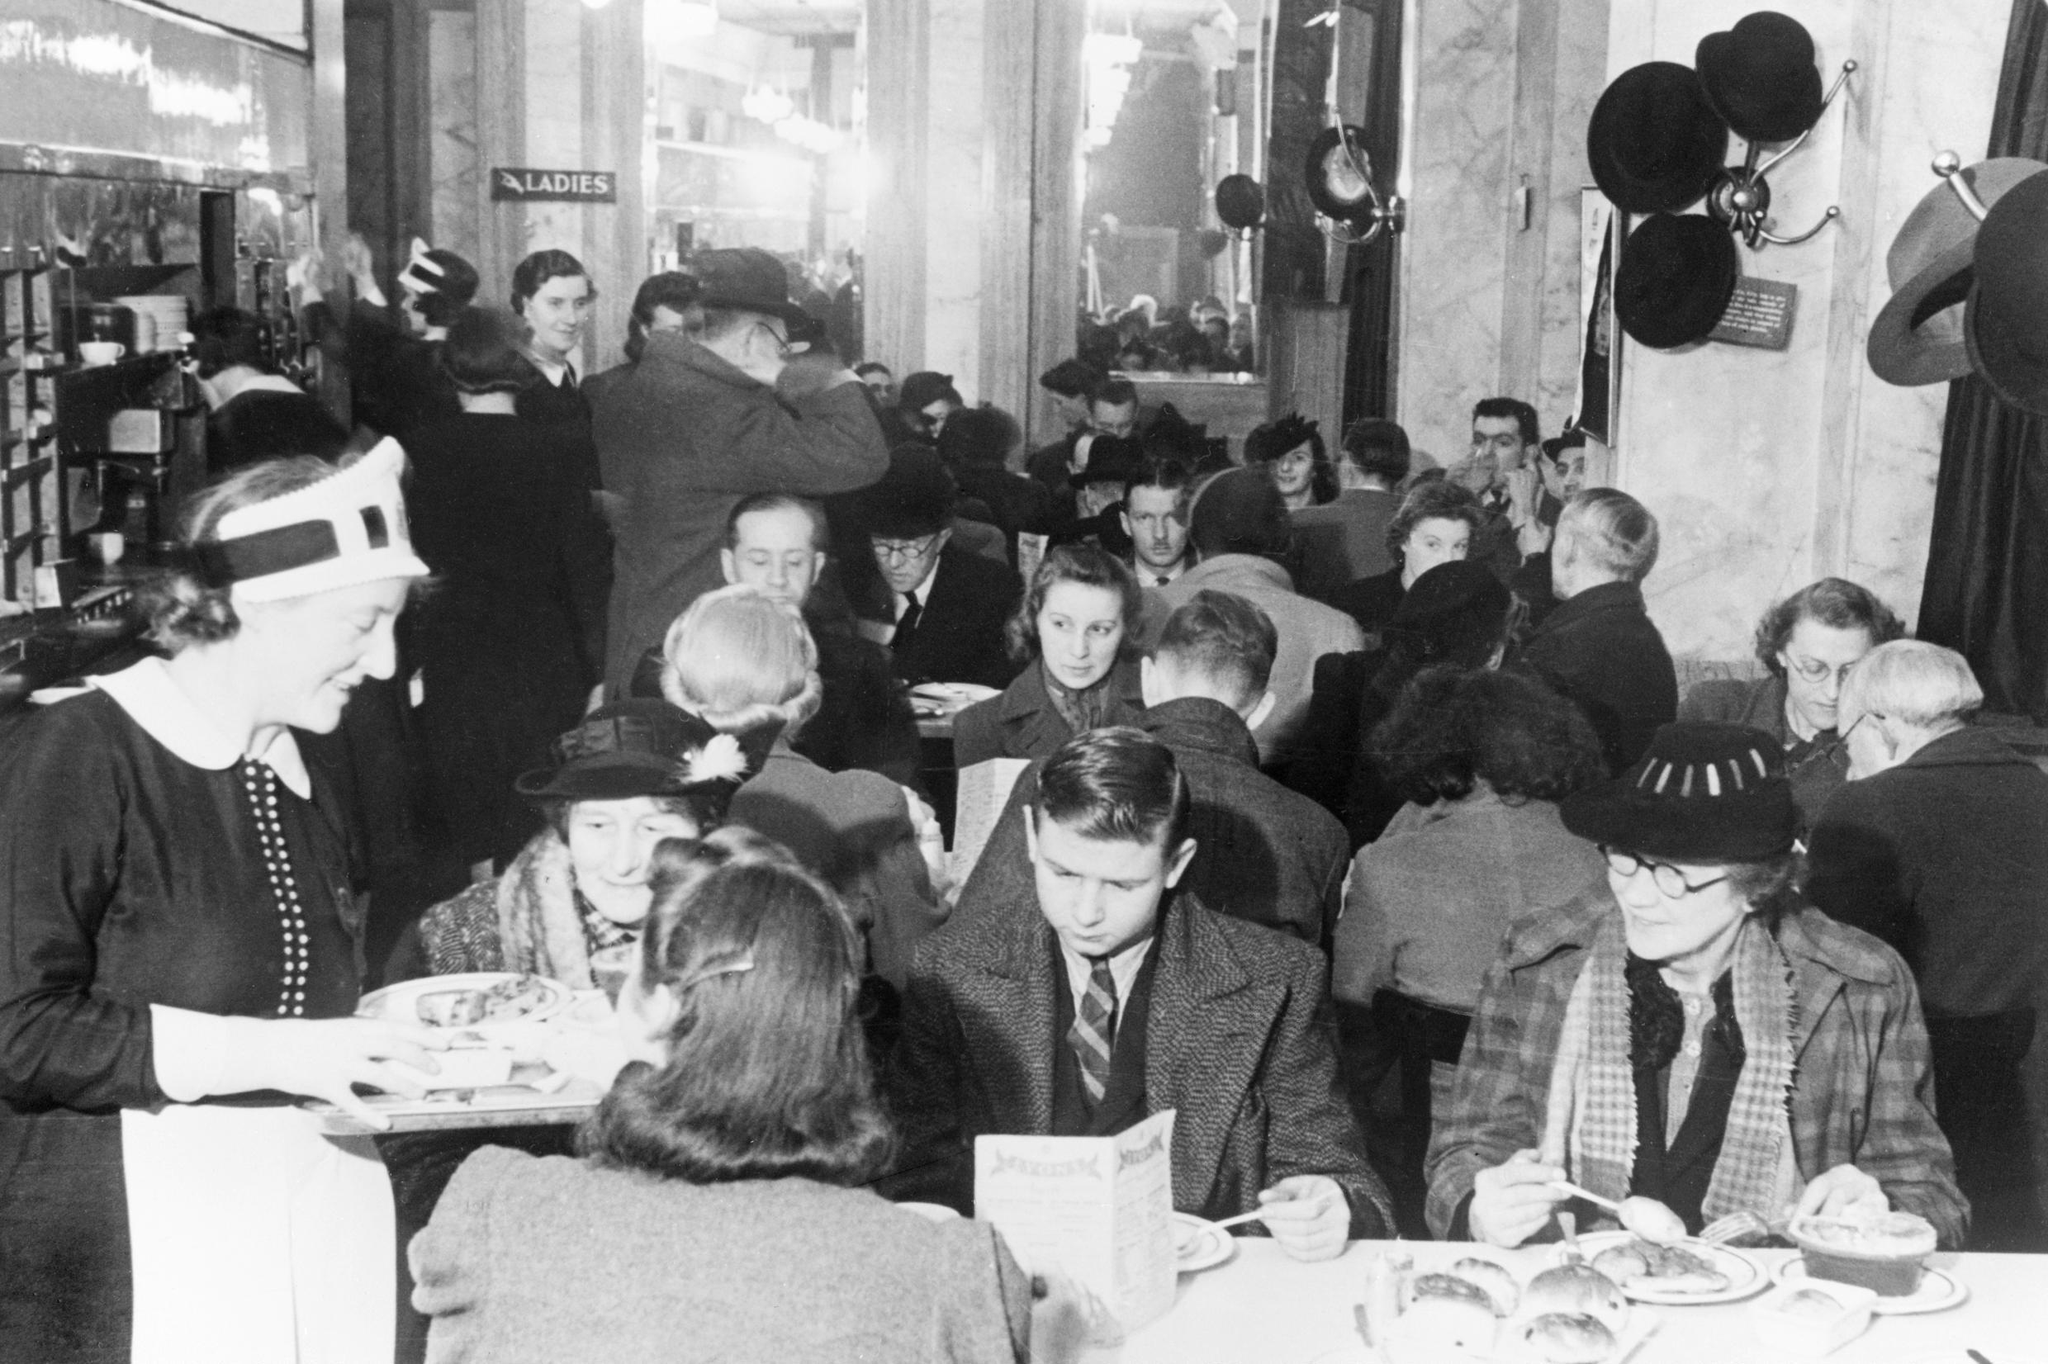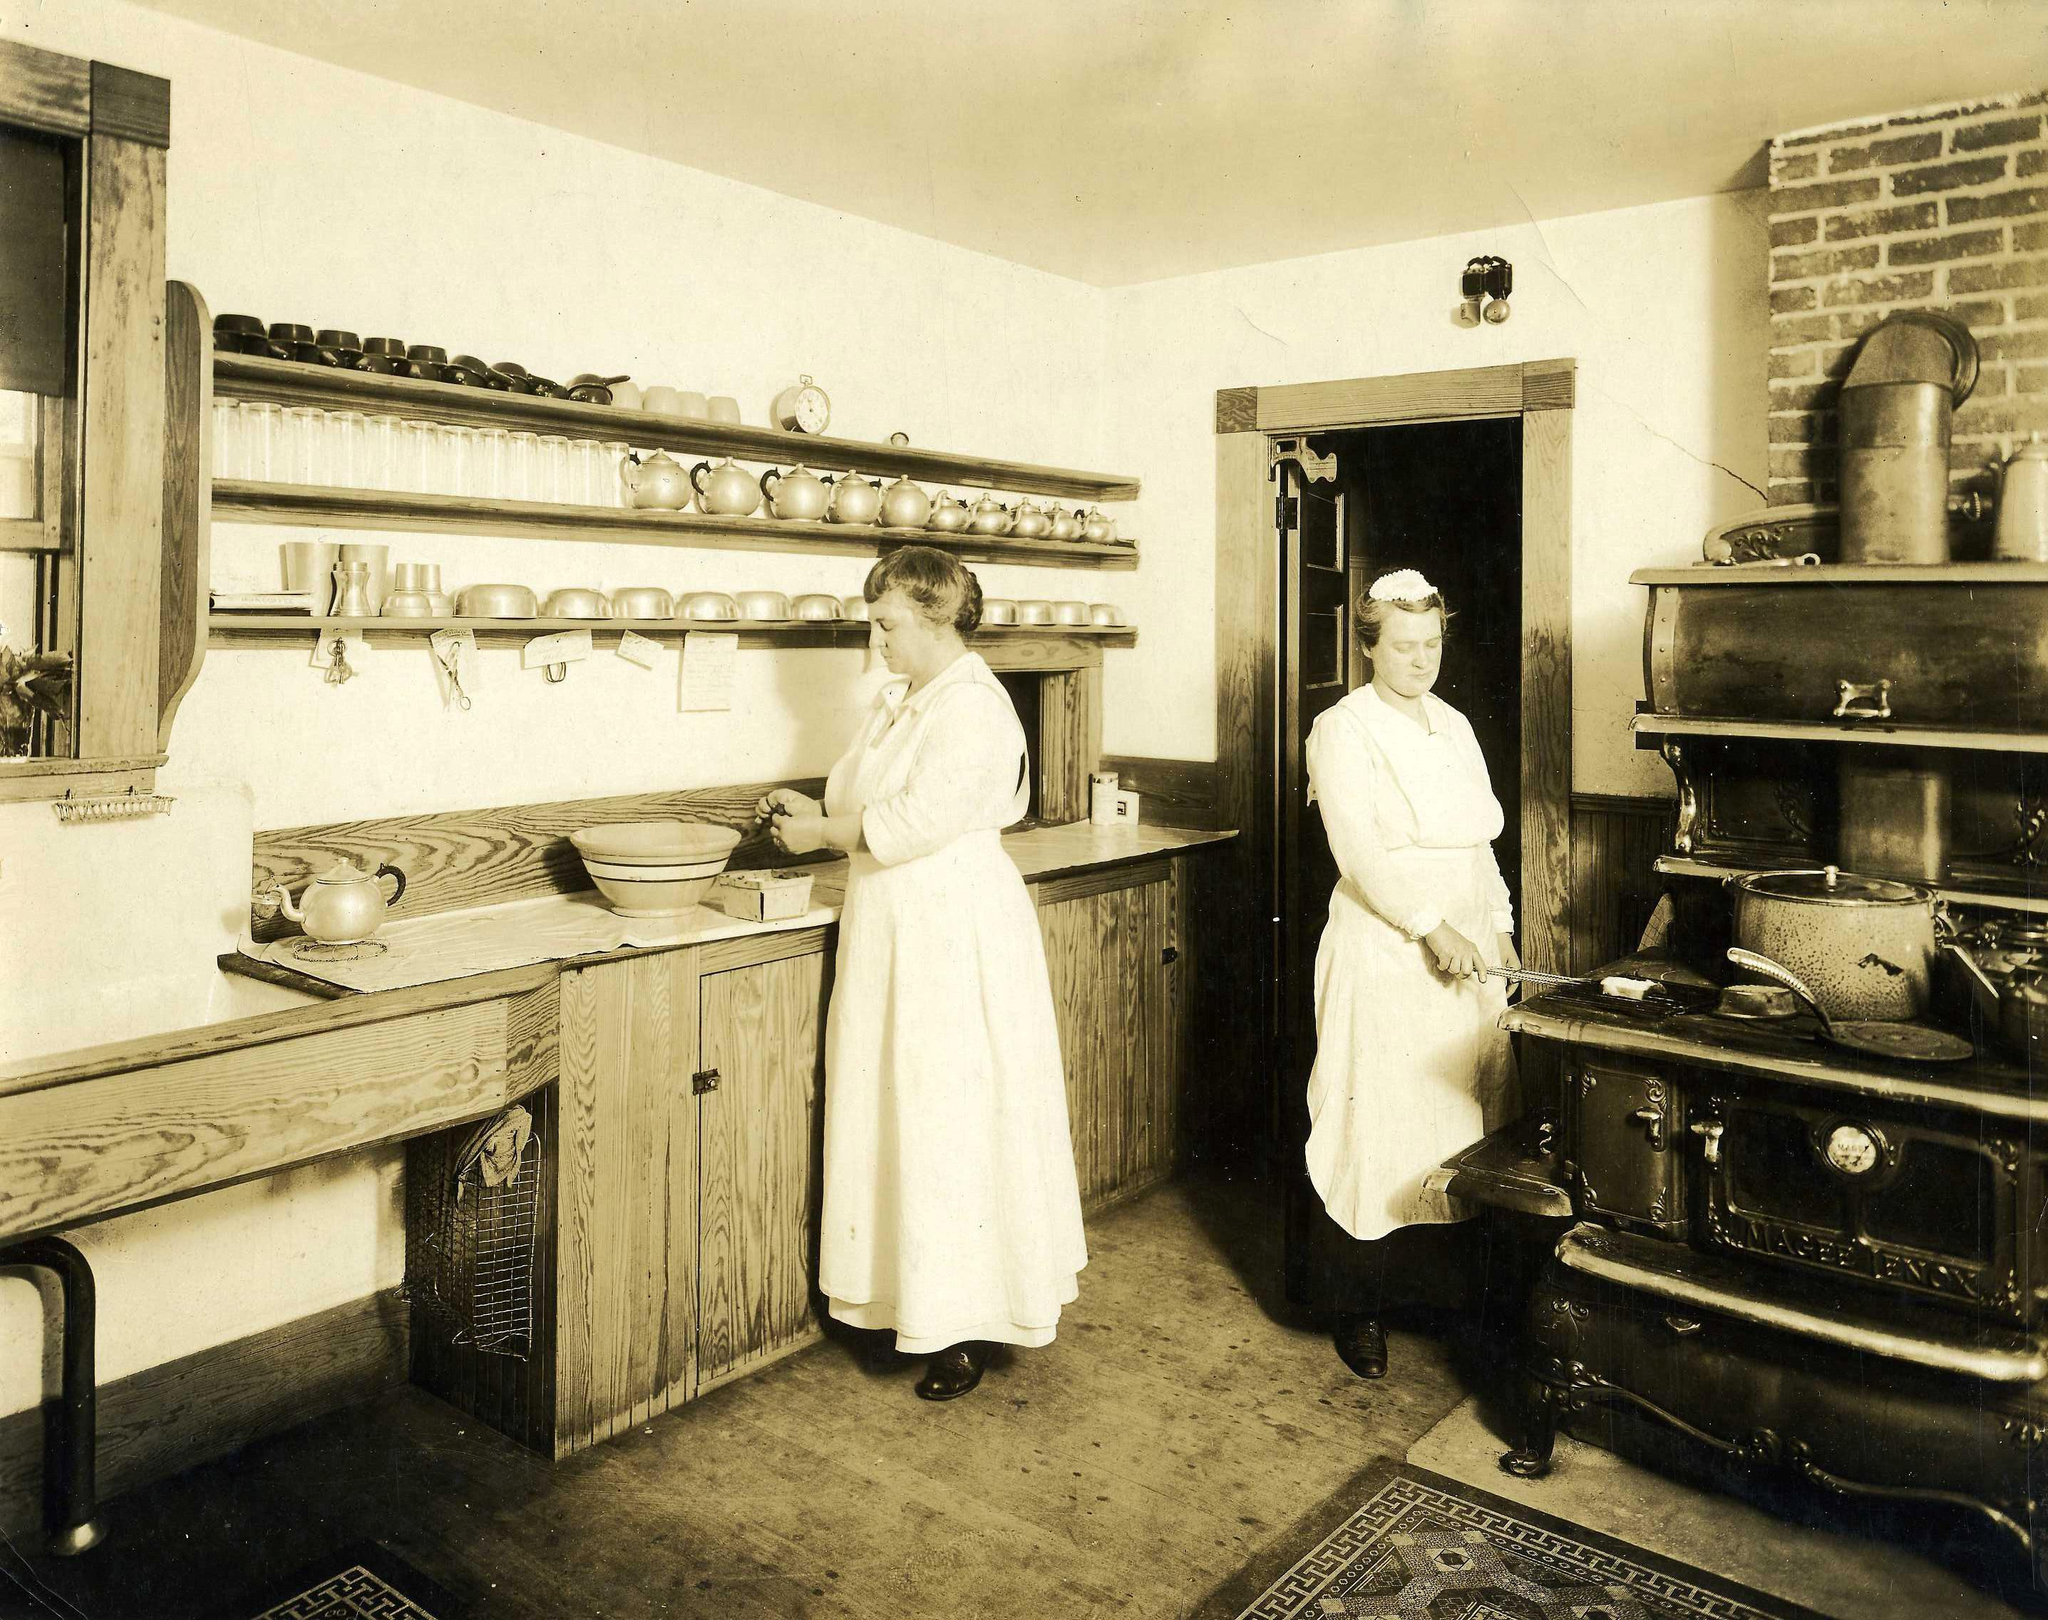The first image is the image on the left, the second image is the image on the right. Examine the images to the left and right. Is the description "The left image shows two people seated at a small table set with coffee cups, and a person standing behind them." accurate? Answer yes or no. No. The first image is the image on the left, the second image is the image on the right. Assess this claim about the two images: "One black and white photo and one sepia photo.". Correct or not? Answer yes or no. Yes. 